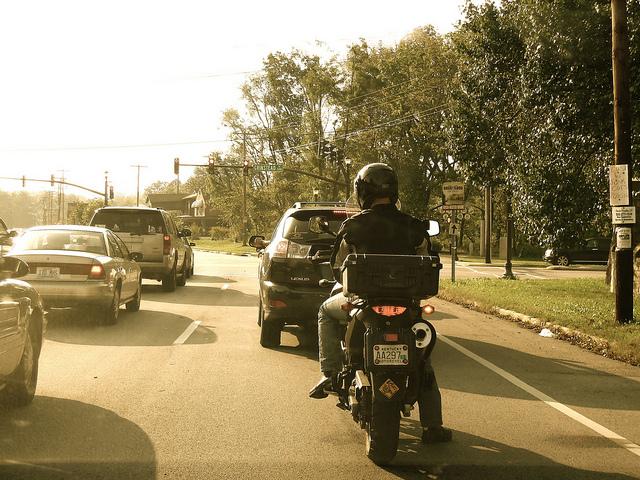Which foot does the biker have on the ground?
Short answer required. Right. Can you make out the bikers tag?
Be succinct. No. What color is the stoplight on?
Write a very short answer. Red. 